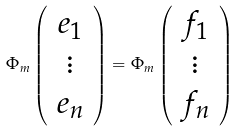Convert formula to latex. <formula><loc_0><loc_0><loc_500><loc_500>\Phi _ { m } \left ( \begin{array} { c } e _ { 1 } \\ \vdots \\ e _ { n } \end{array} \right ) = \Phi _ { m } \left ( \begin{array} { c } f _ { 1 } \\ \vdots \\ f _ { n } \end{array} \right )</formula> 